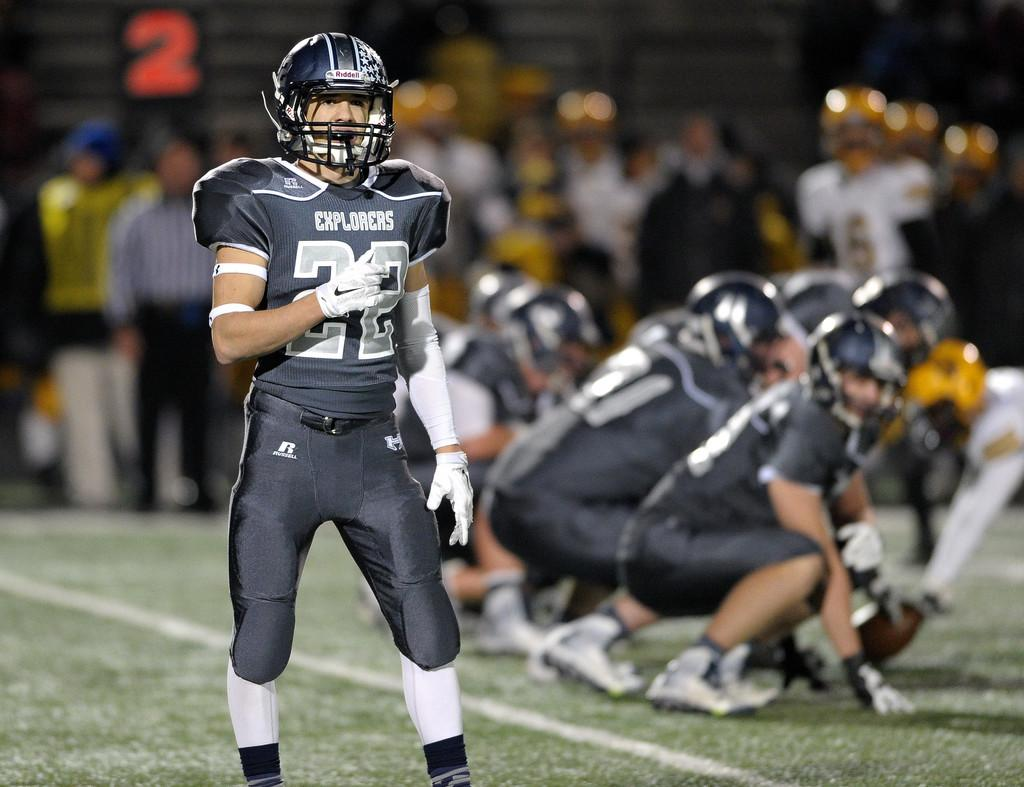How many people are in the image? There are a few people in the image. What can be seen beneath the people's feet? The ground is visible in the image. What type of vegetation is present on the ground? There is grass on the ground. Can you describe the background of the image? The background of the image is blurred. How many rings are visible on the woman's finger in the image? There is no woman present in the image, and therefore no rings can be observed. 